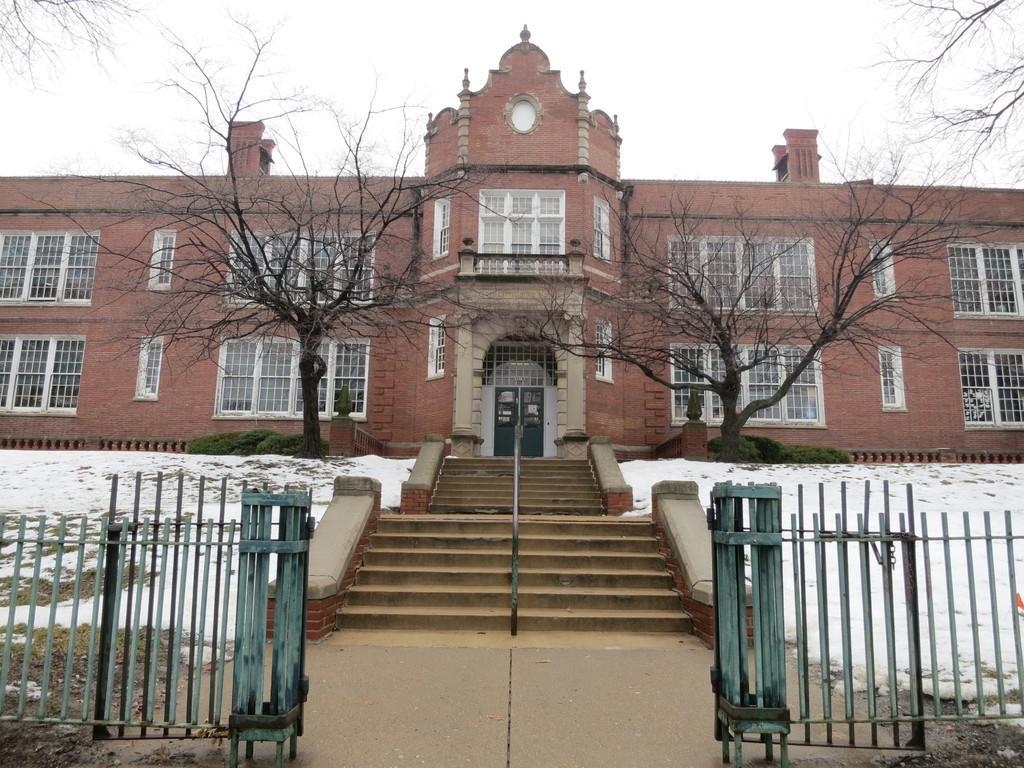Could you give a brief overview of what you see in this image? In this image I can see a building , in front of the building I can see a staircase and green color fence and trees and at the top I can see the sky. 